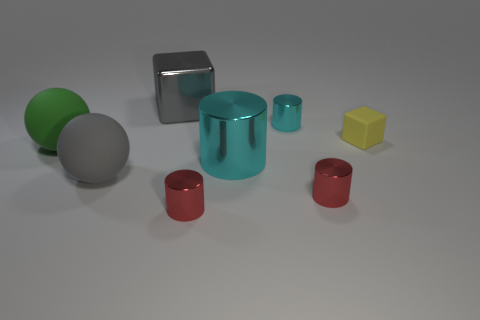What is the yellow block made of?
Keep it short and to the point. Rubber. Is the yellow cube made of the same material as the thing on the left side of the gray ball?
Ensure brevity in your answer.  Yes. The block left of the tiny red shiny cylinder that is on the left side of the large cyan shiny cylinder is what color?
Provide a succinct answer. Gray. What is the size of the object that is both behind the big shiny cylinder and on the right side of the tiny cyan cylinder?
Your response must be concise. Small. How many other objects are there of the same shape as the small yellow thing?
Provide a succinct answer. 1. There is a gray metal object; does it have the same shape as the yellow thing on the right side of the tiny cyan thing?
Keep it short and to the point. Yes. How many big rubber balls are in front of the large green sphere?
Offer a very short reply. 1. Is the shape of the large metallic object that is behind the big cyan object the same as  the tiny yellow rubber thing?
Your answer should be very brief. Yes. There is a cylinder that is behind the yellow rubber object; what is its color?
Keep it short and to the point. Cyan. The tiny yellow thing that is the same material as the green ball is what shape?
Your answer should be very brief. Cube. 